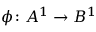Convert formula to latex. <formula><loc_0><loc_0><loc_500><loc_500>\phi \colon A ^ { 1 } \to B ^ { 1 }</formula> 